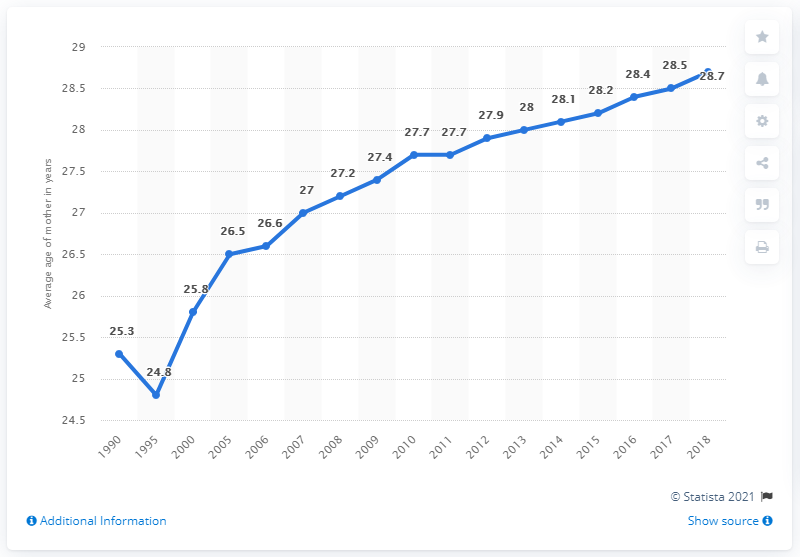Draw attention to some important aspects in this diagram. In the year 1995, the average age of women who gave birth to live children increased by 3.9 years compared to previous years. 